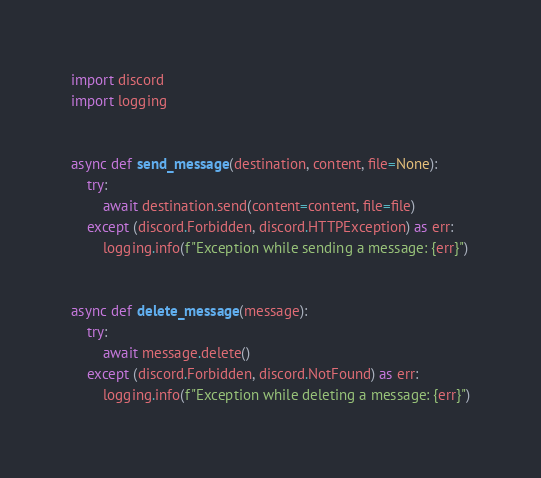Convert code to text. <code><loc_0><loc_0><loc_500><loc_500><_Python_>import discord
import logging


async def send_message(destination, content, file=None):
    try:
        await destination.send(content=content, file=file)
    except (discord.Forbidden, discord.HTTPException) as err:
        logging.info(f"Exception while sending a message: {err}")


async def delete_message(message):
    try:
        await message.delete()
    except (discord.Forbidden, discord.NotFound) as err:
        logging.info(f"Exception while deleting a message: {err}")

</code> 